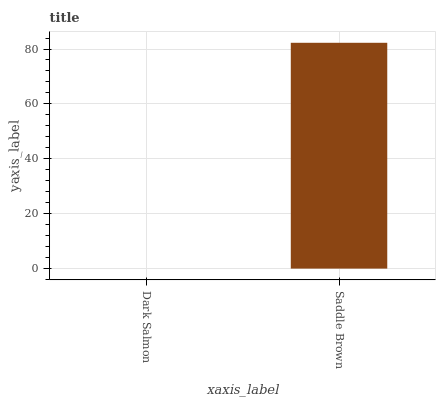Is Dark Salmon the minimum?
Answer yes or no. Yes. Is Saddle Brown the maximum?
Answer yes or no. Yes. Is Saddle Brown the minimum?
Answer yes or no. No. Is Saddle Brown greater than Dark Salmon?
Answer yes or no. Yes. Is Dark Salmon less than Saddle Brown?
Answer yes or no. Yes. Is Dark Salmon greater than Saddle Brown?
Answer yes or no. No. Is Saddle Brown less than Dark Salmon?
Answer yes or no. No. Is Saddle Brown the high median?
Answer yes or no. Yes. Is Dark Salmon the low median?
Answer yes or no. Yes. Is Dark Salmon the high median?
Answer yes or no. No. Is Saddle Brown the low median?
Answer yes or no. No. 